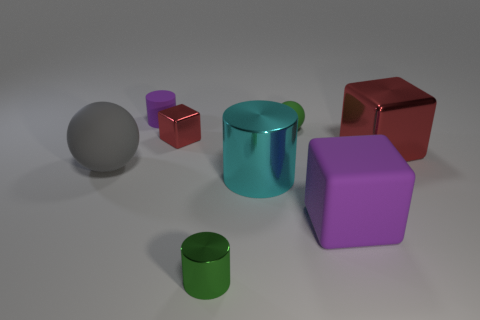Add 1 gray matte cylinders. How many objects exist? 9 Subtract all blocks. How many objects are left? 5 Subtract 1 gray balls. How many objects are left? 7 Subtract all brown metal balls. Subtract all large matte spheres. How many objects are left? 7 Add 8 tiny red metal blocks. How many tiny red metal blocks are left? 9 Add 3 red cubes. How many red cubes exist? 5 